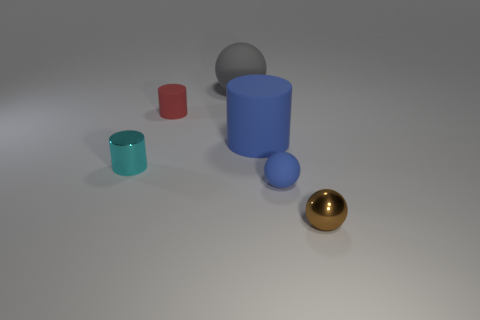Is the shape of the red object the same as the big object left of the big blue rubber cylinder?
Your answer should be compact. No. How many other things are there of the same material as the big cylinder?
Your response must be concise. 3. The rubber sphere that is behind the small shiny thing behind the small metal thing on the right side of the red rubber object is what color?
Keep it short and to the point. Gray. The small thing that is behind the metallic thing that is on the left side of the small red thing is what shape?
Your response must be concise. Cylinder. Is the number of tiny blue things behind the large gray rubber sphere greater than the number of gray balls?
Offer a very short reply. No. There is a tiny metal thing that is right of the cyan metallic thing; is its shape the same as the red matte object?
Your answer should be compact. No. Is there a tiny blue matte thing that has the same shape as the small brown object?
Offer a very short reply. Yes. How many things are either tiny things in front of the tiny red rubber object or yellow rubber cylinders?
Your answer should be very brief. 3. Are there more small matte cylinders than large yellow matte objects?
Offer a very short reply. Yes. Is there a green matte cylinder of the same size as the red matte thing?
Ensure brevity in your answer.  No. 